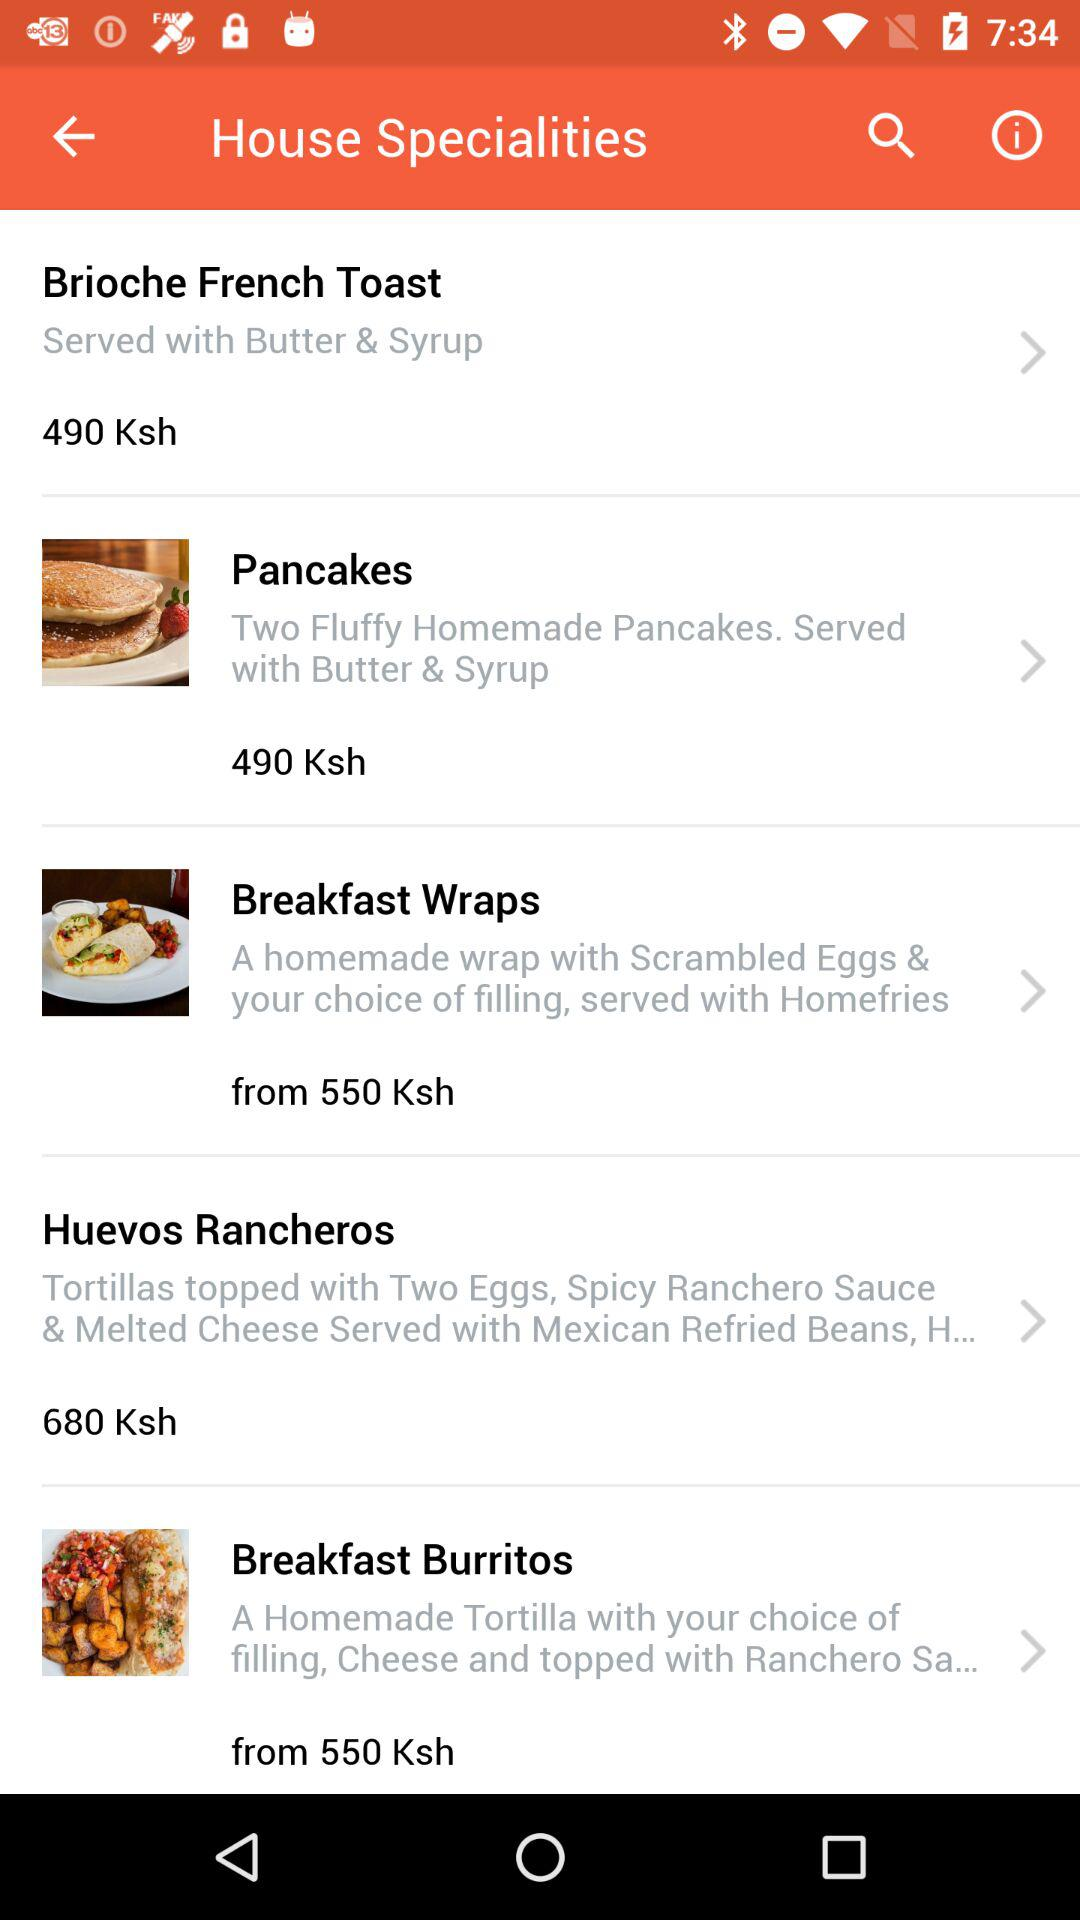What is the price of "Brioche French Toast"? The price of "Brioche French Toast" is 490 Ksh. 